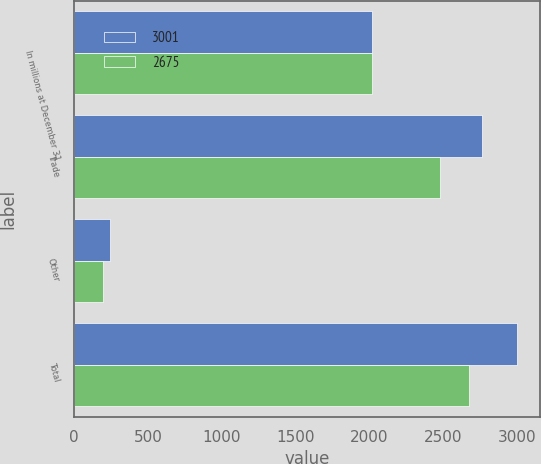Convert chart to OTSL. <chart><loc_0><loc_0><loc_500><loc_500><stacked_bar_chart><ecel><fcel>In millions at December 31<fcel>Trade<fcel>Other<fcel>Total<nl><fcel>3001<fcel>2016<fcel>2759<fcel>242<fcel>3001<nl><fcel>2675<fcel>2015<fcel>2480<fcel>195<fcel>2675<nl></chart> 